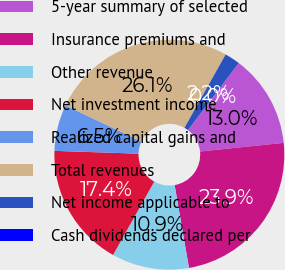Convert chart to OTSL. <chart><loc_0><loc_0><loc_500><loc_500><pie_chart><fcel>5-year summary of selected<fcel>Insurance premiums and<fcel>Other revenue<fcel>Net investment income<fcel>Realized capital gains and<fcel>Total revenues<fcel>Net income applicable to<fcel>Cash dividends declared per<nl><fcel>13.04%<fcel>23.91%<fcel>10.87%<fcel>17.39%<fcel>6.52%<fcel>26.09%<fcel>2.17%<fcel>0.0%<nl></chart> 